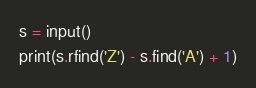Convert code to text. <code><loc_0><loc_0><loc_500><loc_500><_Python_>s = input()
print(s.rfind('Z') - s.find('A') + 1)</code> 